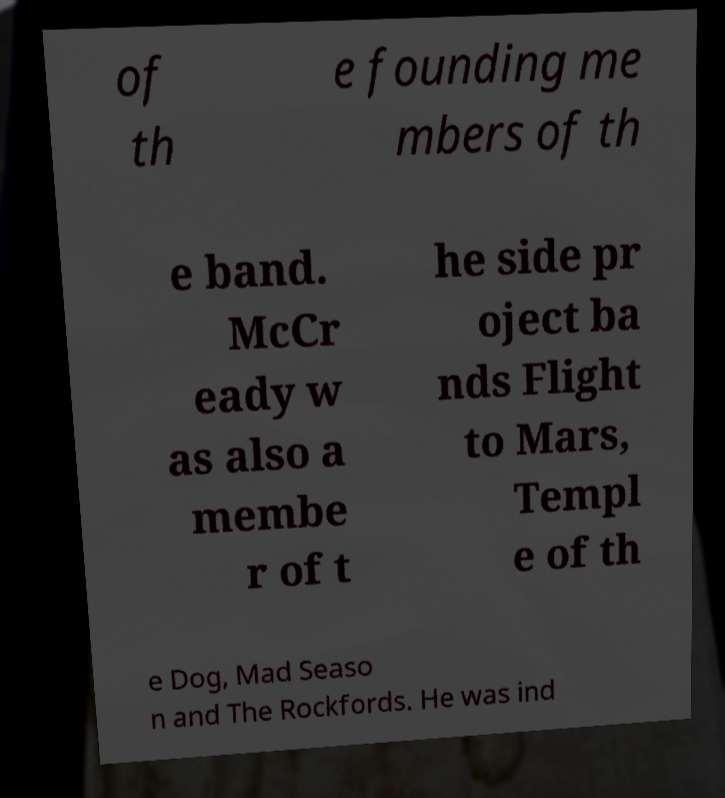Please identify and transcribe the text found in this image. of th e founding me mbers of th e band. McCr eady w as also a membe r of t he side pr oject ba nds Flight to Mars, Templ e of th e Dog, Mad Seaso n and The Rockfords. He was ind 